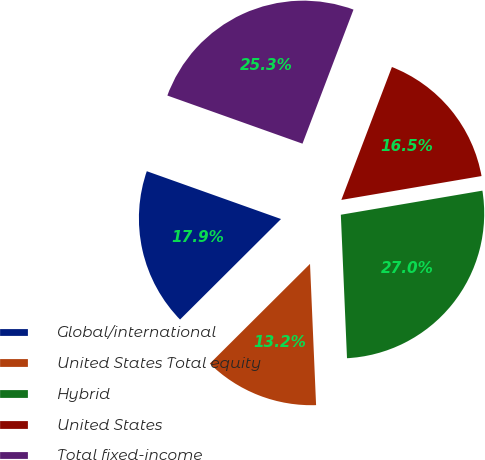Convert chart to OTSL. <chart><loc_0><loc_0><loc_500><loc_500><pie_chart><fcel>Global/international<fcel>United States Total equity<fcel>Hybrid<fcel>United States<fcel>Total fixed-income<nl><fcel>17.91%<fcel>13.22%<fcel>27.0%<fcel>16.53%<fcel>25.34%<nl></chart> 